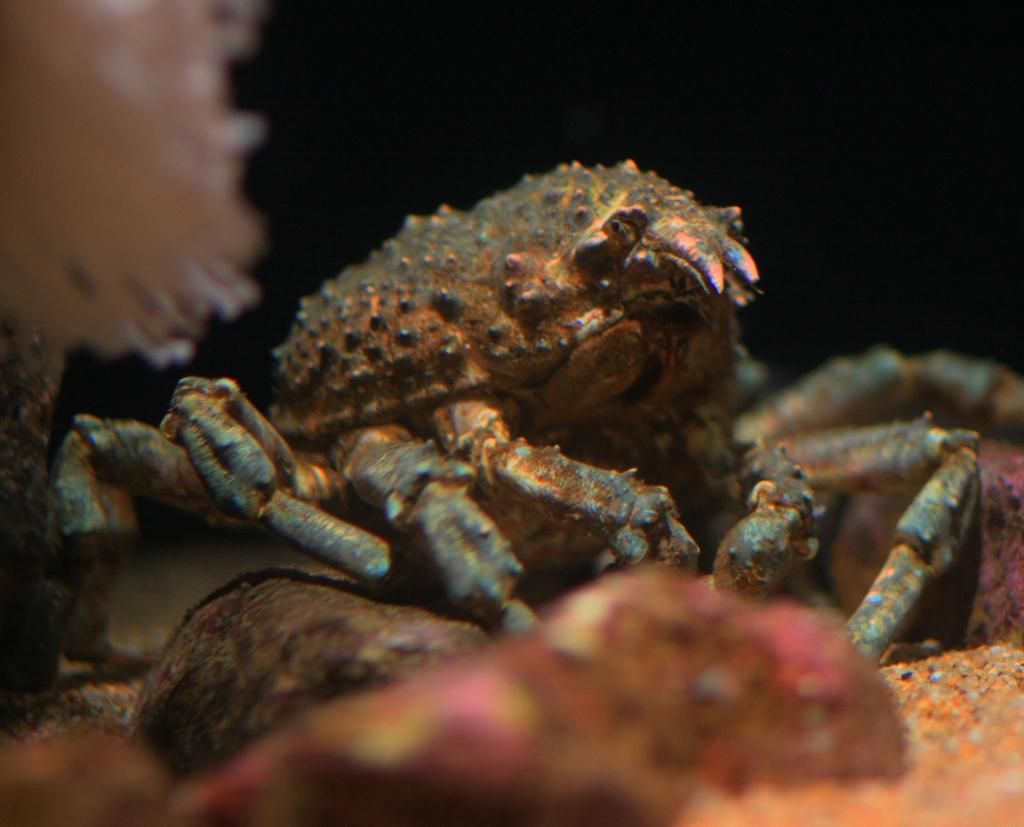What is the setting of the image? The image appears to be taken in the water. What type of marine creature can be seen in the image? There is a crab in the image. What type of underwater structure is visible in the image? There is coral in the image. How would you describe the lighting in the image? The background of the image is dark. What other objects can be seen in the image besides the crab and coral? There are objects that resemble stones in the image. What is the name of the person who took the image? The facts provided do not mention the name of the person who took the image. What is the top of the coral like in the image? The facts provided do not describe the top of the coral in the image. 